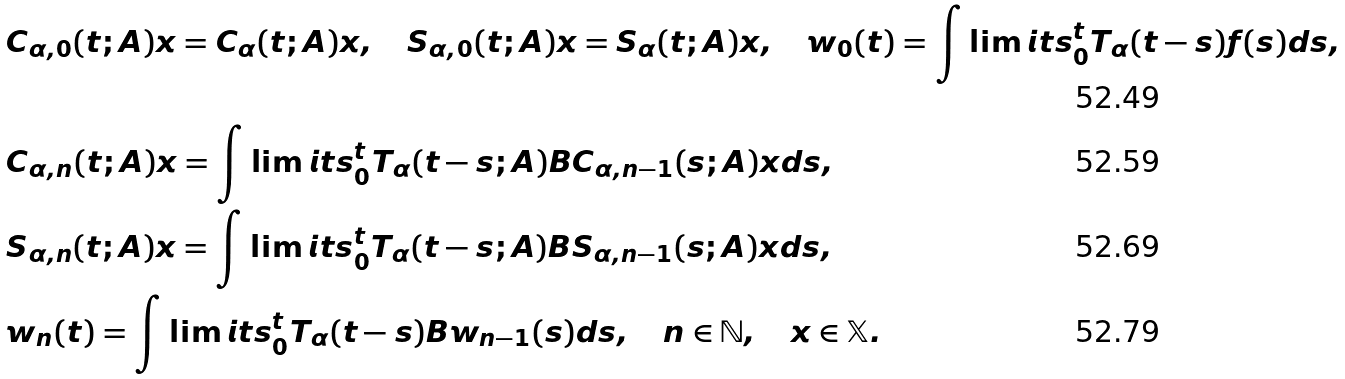Convert formula to latex. <formula><loc_0><loc_0><loc_500><loc_500>& C _ { \alpha , 0 } ( t ; A ) x = C _ { \alpha } ( t ; A ) x , \quad S _ { \alpha , 0 } ( t ; A ) x = S _ { \alpha } ( t ; A ) x , \quad w _ { 0 } ( t ) = \int \lim i t s _ { 0 } ^ { t } T _ { \alpha } ( t - s ) f ( s ) d s , \\ & C _ { \alpha , n } ( t ; A ) x = \int \lim i t s _ { 0 } ^ { t } T _ { \alpha } ( t - s ; A ) B C _ { \alpha , n - 1 } ( s ; A ) x d s , \\ & S _ { \alpha , n } ( t ; A ) x = \int \lim i t s _ { 0 } ^ { t } T _ { \alpha } ( t - s ; A ) B S _ { \alpha , n - 1 } ( s ; A ) x d s , \\ & w _ { n } ( t ) = \int \lim i t s _ { 0 } ^ { t } T _ { \alpha } ( t - s ) B w _ { n - 1 } ( s ) d s , \quad n \in \mathbb { N } , \quad x \in \mathbb { X } .</formula> 